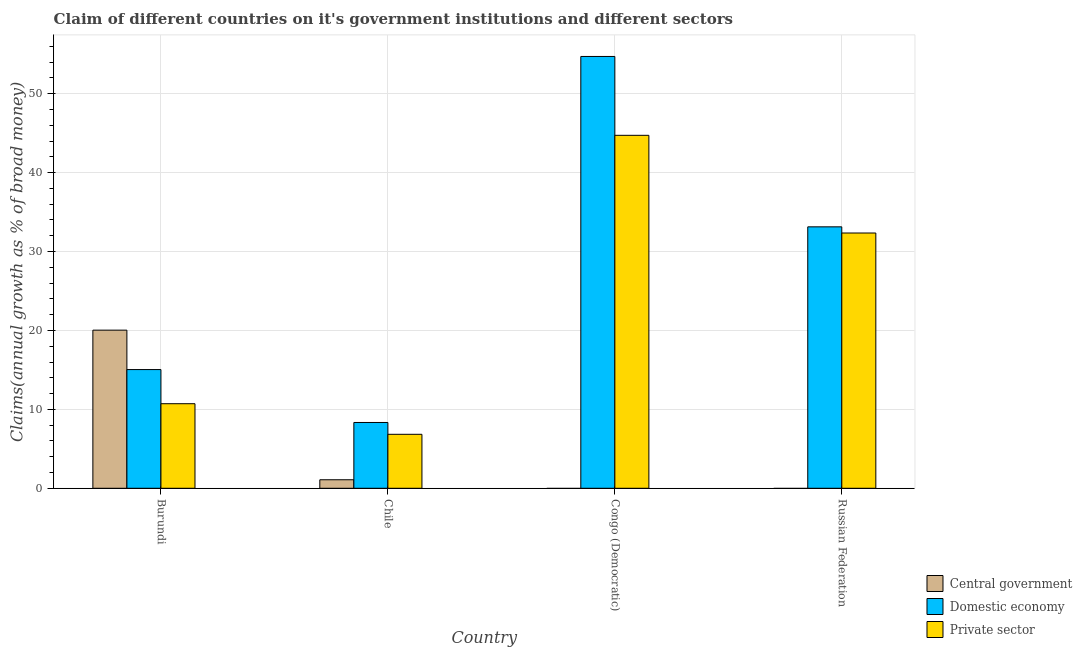How many different coloured bars are there?
Provide a succinct answer. 3. How many groups of bars are there?
Provide a succinct answer. 4. How many bars are there on the 3rd tick from the left?
Offer a very short reply. 2. What is the label of the 4th group of bars from the left?
Your answer should be very brief. Russian Federation. In how many cases, is the number of bars for a given country not equal to the number of legend labels?
Keep it short and to the point. 2. What is the percentage of claim on the domestic economy in Burundi?
Your answer should be very brief. 15.04. Across all countries, what is the maximum percentage of claim on the central government?
Provide a succinct answer. 20.04. Across all countries, what is the minimum percentage of claim on the central government?
Provide a succinct answer. 0. In which country was the percentage of claim on the domestic economy maximum?
Your answer should be very brief. Congo (Democratic). What is the total percentage of claim on the domestic economy in the graph?
Your answer should be compact. 111.22. What is the difference between the percentage of claim on the domestic economy in Burundi and that in Chile?
Your answer should be very brief. 6.7. What is the difference between the percentage of claim on the central government in Burundi and the percentage of claim on the domestic economy in Russian Federation?
Provide a succinct answer. -13.09. What is the average percentage of claim on the private sector per country?
Your response must be concise. 23.65. What is the difference between the percentage of claim on the private sector and percentage of claim on the central government in Burundi?
Make the answer very short. -9.32. In how many countries, is the percentage of claim on the private sector greater than 32 %?
Offer a very short reply. 2. What is the ratio of the percentage of claim on the private sector in Chile to that in Congo (Democratic)?
Your answer should be compact. 0.15. Is the percentage of claim on the domestic economy in Burundi less than that in Russian Federation?
Your answer should be very brief. Yes. Is the difference between the percentage of claim on the domestic economy in Chile and Russian Federation greater than the difference between the percentage of claim on the private sector in Chile and Russian Federation?
Ensure brevity in your answer.  Yes. What is the difference between the highest and the second highest percentage of claim on the private sector?
Provide a short and direct response. 12.38. What is the difference between the highest and the lowest percentage of claim on the central government?
Provide a succinct answer. 20.04. How many bars are there?
Your response must be concise. 10. Are all the bars in the graph horizontal?
Your answer should be compact. No. Does the graph contain grids?
Offer a terse response. Yes. How many legend labels are there?
Ensure brevity in your answer.  3. How are the legend labels stacked?
Offer a terse response. Vertical. What is the title of the graph?
Your response must be concise. Claim of different countries on it's government institutions and different sectors. What is the label or title of the X-axis?
Provide a succinct answer. Country. What is the label or title of the Y-axis?
Ensure brevity in your answer.  Claims(annual growth as % of broad money). What is the Claims(annual growth as % of broad money) of Central government in Burundi?
Your response must be concise. 20.04. What is the Claims(annual growth as % of broad money) of Domestic economy in Burundi?
Make the answer very short. 15.04. What is the Claims(annual growth as % of broad money) in Private sector in Burundi?
Your answer should be compact. 10.72. What is the Claims(annual growth as % of broad money) of Central government in Chile?
Your answer should be very brief. 1.08. What is the Claims(annual growth as % of broad money) in Domestic economy in Chile?
Provide a succinct answer. 8.34. What is the Claims(annual growth as % of broad money) in Private sector in Chile?
Keep it short and to the point. 6.84. What is the Claims(annual growth as % of broad money) of Central government in Congo (Democratic)?
Keep it short and to the point. 0. What is the Claims(annual growth as % of broad money) of Domestic economy in Congo (Democratic)?
Your response must be concise. 54.71. What is the Claims(annual growth as % of broad money) of Private sector in Congo (Democratic)?
Your response must be concise. 44.72. What is the Claims(annual growth as % of broad money) of Central government in Russian Federation?
Offer a terse response. 0. What is the Claims(annual growth as % of broad money) of Domestic economy in Russian Federation?
Provide a short and direct response. 33.13. What is the Claims(annual growth as % of broad money) of Private sector in Russian Federation?
Your response must be concise. 32.34. Across all countries, what is the maximum Claims(annual growth as % of broad money) of Central government?
Your answer should be very brief. 20.04. Across all countries, what is the maximum Claims(annual growth as % of broad money) of Domestic economy?
Provide a succinct answer. 54.71. Across all countries, what is the maximum Claims(annual growth as % of broad money) in Private sector?
Your response must be concise. 44.72. Across all countries, what is the minimum Claims(annual growth as % of broad money) in Domestic economy?
Make the answer very short. 8.34. Across all countries, what is the minimum Claims(annual growth as % of broad money) in Private sector?
Keep it short and to the point. 6.84. What is the total Claims(annual growth as % of broad money) of Central government in the graph?
Provide a succinct answer. 21.12. What is the total Claims(annual growth as % of broad money) of Domestic economy in the graph?
Your answer should be very brief. 111.22. What is the total Claims(annual growth as % of broad money) of Private sector in the graph?
Keep it short and to the point. 94.62. What is the difference between the Claims(annual growth as % of broad money) of Central government in Burundi and that in Chile?
Ensure brevity in your answer.  18.96. What is the difference between the Claims(annual growth as % of broad money) of Domestic economy in Burundi and that in Chile?
Offer a very short reply. 6.7. What is the difference between the Claims(annual growth as % of broad money) in Private sector in Burundi and that in Chile?
Your answer should be very brief. 3.88. What is the difference between the Claims(annual growth as % of broad money) of Domestic economy in Burundi and that in Congo (Democratic)?
Keep it short and to the point. -39.67. What is the difference between the Claims(annual growth as % of broad money) in Private sector in Burundi and that in Congo (Democratic)?
Provide a succinct answer. -34.01. What is the difference between the Claims(annual growth as % of broad money) in Domestic economy in Burundi and that in Russian Federation?
Make the answer very short. -18.08. What is the difference between the Claims(annual growth as % of broad money) in Private sector in Burundi and that in Russian Federation?
Offer a terse response. -21.63. What is the difference between the Claims(annual growth as % of broad money) in Domestic economy in Chile and that in Congo (Democratic)?
Your answer should be compact. -46.37. What is the difference between the Claims(annual growth as % of broad money) of Private sector in Chile and that in Congo (Democratic)?
Your answer should be compact. -37.88. What is the difference between the Claims(annual growth as % of broad money) of Domestic economy in Chile and that in Russian Federation?
Your answer should be compact. -24.79. What is the difference between the Claims(annual growth as % of broad money) of Private sector in Chile and that in Russian Federation?
Ensure brevity in your answer.  -25.51. What is the difference between the Claims(annual growth as % of broad money) in Domestic economy in Congo (Democratic) and that in Russian Federation?
Your answer should be very brief. 21.59. What is the difference between the Claims(annual growth as % of broad money) in Private sector in Congo (Democratic) and that in Russian Federation?
Give a very brief answer. 12.38. What is the difference between the Claims(annual growth as % of broad money) of Central government in Burundi and the Claims(annual growth as % of broad money) of Domestic economy in Chile?
Offer a very short reply. 11.7. What is the difference between the Claims(annual growth as % of broad money) in Central government in Burundi and the Claims(annual growth as % of broad money) in Private sector in Chile?
Your response must be concise. 13.2. What is the difference between the Claims(annual growth as % of broad money) in Domestic economy in Burundi and the Claims(annual growth as % of broad money) in Private sector in Chile?
Provide a short and direct response. 8.2. What is the difference between the Claims(annual growth as % of broad money) of Central government in Burundi and the Claims(annual growth as % of broad money) of Domestic economy in Congo (Democratic)?
Offer a terse response. -34.68. What is the difference between the Claims(annual growth as % of broad money) in Central government in Burundi and the Claims(annual growth as % of broad money) in Private sector in Congo (Democratic)?
Your answer should be very brief. -24.69. What is the difference between the Claims(annual growth as % of broad money) in Domestic economy in Burundi and the Claims(annual growth as % of broad money) in Private sector in Congo (Democratic)?
Ensure brevity in your answer.  -29.68. What is the difference between the Claims(annual growth as % of broad money) of Central government in Burundi and the Claims(annual growth as % of broad money) of Domestic economy in Russian Federation?
Keep it short and to the point. -13.09. What is the difference between the Claims(annual growth as % of broad money) of Central government in Burundi and the Claims(annual growth as % of broad money) of Private sector in Russian Federation?
Provide a short and direct response. -12.31. What is the difference between the Claims(annual growth as % of broad money) in Domestic economy in Burundi and the Claims(annual growth as % of broad money) in Private sector in Russian Federation?
Your answer should be compact. -17.3. What is the difference between the Claims(annual growth as % of broad money) in Central government in Chile and the Claims(annual growth as % of broad money) in Domestic economy in Congo (Democratic)?
Your answer should be compact. -53.63. What is the difference between the Claims(annual growth as % of broad money) in Central government in Chile and the Claims(annual growth as % of broad money) in Private sector in Congo (Democratic)?
Offer a very short reply. -43.64. What is the difference between the Claims(annual growth as % of broad money) in Domestic economy in Chile and the Claims(annual growth as % of broad money) in Private sector in Congo (Democratic)?
Keep it short and to the point. -36.38. What is the difference between the Claims(annual growth as % of broad money) of Central government in Chile and the Claims(annual growth as % of broad money) of Domestic economy in Russian Federation?
Ensure brevity in your answer.  -32.05. What is the difference between the Claims(annual growth as % of broad money) in Central government in Chile and the Claims(annual growth as % of broad money) in Private sector in Russian Federation?
Provide a short and direct response. -31.26. What is the difference between the Claims(annual growth as % of broad money) of Domestic economy in Chile and the Claims(annual growth as % of broad money) of Private sector in Russian Federation?
Your response must be concise. -24.01. What is the difference between the Claims(annual growth as % of broad money) of Domestic economy in Congo (Democratic) and the Claims(annual growth as % of broad money) of Private sector in Russian Federation?
Offer a terse response. 22.37. What is the average Claims(annual growth as % of broad money) of Central government per country?
Ensure brevity in your answer.  5.28. What is the average Claims(annual growth as % of broad money) of Domestic economy per country?
Keep it short and to the point. 27.8. What is the average Claims(annual growth as % of broad money) in Private sector per country?
Your answer should be compact. 23.66. What is the difference between the Claims(annual growth as % of broad money) of Central government and Claims(annual growth as % of broad money) of Domestic economy in Burundi?
Your answer should be very brief. 4.99. What is the difference between the Claims(annual growth as % of broad money) of Central government and Claims(annual growth as % of broad money) of Private sector in Burundi?
Your answer should be compact. 9.32. What is the difference between the Claims(annual growth as % of broad money) of Domestic economy and Claims(annual growth as % of broad money) of Private sector in Burundi?
Provide a short and direct response. 4.33. What is the difference between the Claims(annual growth as % of broad money) in Central government and Claims(annual growth as % of broad money) in Domestic economy in Chile?
Provide a succinct answer. -7.26. What is the difference between the Claims(annual growth as % of broad money) in Central government and Claims(annual growth as % of broad money) in Private sector in Chile?
Ensure brevity in your answer.  -5.76. What is the difference between the Claims(annual growth as % of broad money) of Domestic economy and Claims(annual growth as % of broad money) of Private sector in Chile?
Offer a very short reply. 1.5. What is the difference between the Claims(annual growth as % of broad money) in Domestic economy and Claims(annual growth as % of broad money) in Private sector in Congo (Democratic)?
Provide a short and direct response. 9.99. What is the difference between the Claims(annual growth as % of broad money) in Domestic economy and Claims(annual growth as % of broad money) in Private sector in Russian Federation?
Your answer should be compact. 0.78. What is the ratio of the Claims(annual growth as % of broad money) in Central government in Burundi to that in Chile?
Keep it short and to the point. 18.55. What is the ratio of the Claims(annual growth as % of broad money) in Domestic economy in Burundi to that in Chile?
Ensure brevity in your answer.  1.8. What is the ratio of the Claims(annual growth as % of broad money) in Private sector in Burundi to that in Chile?
Give a very brief answer. 1.57. What is the ratio of the Claims(annual growth as % of broad money) of Domestic economy in Burundi to that in Congo (Democratic)?
Provide a short and direct response. 0.27. What is the ratio of the Claims(annual growth as % of broad money) of Private sector in Burundi to that in Congo (Democratic)?
Offer a very short reply. 0.24. What is the ratio of the Claims(annual growth as % of broad money) of Domestic economy in Burundi to that in Russian Federation?
Offer a terse response. 0.45. What is the ratio of the Claims(annual growth as % of broad money) of Private sector in Burundi to that in Russian Federation?
Make the answer very short. 0.33. What is the ratio of the Claims(annual growth as % of broad money) in Domestic economy in Chile to that in Congo (Democratic)?
Ensure brevity in your answer.  0.15. What is the ratio of the Claims(annual growth as % of broad money) of Private sector in Chile to that in Congo (Democratic)?
Keep it short and to the point. 0.15. What is the ratio of the Claims(annual growth as % of broad money) of Domestic economy in Chile to that in Russian Federation?
Offer a very short reply. 0.25. What is the ratio of the Claims(annual growth as % of broad money) of Private sector in Chile to that in Russian Federation?
Your response must be concise. 0.21. What is the ratio of the Claims(annual growth as % of broad money) of Domestic economy in Congo (Democratic) to that in Russian Federation?
Make the answer very short. 1.65. What is the ratio of the Claims(annual growth as % of broad money) in Private sector in Congo (Democratic) to that in Russian Federation?
Your answer should be very brief. 1.38. What is the difference between the highest and the second highest Claims(annual growth as % of broad money) in Domestic economy?
Keep it short and to the point. 21.59. What is the difference between the highest and the second highest Claims(annual growth as % of broad money) of Private sector?
Keep it short and to the point. 12.38. What is the difference between the highest and the lowest Claims(annual growth as % of broad money) in Central government?
Your answer should be very brief. 20.04. What is the difference between the highest and the lowest Claims(annual growth as % of broad money) of Domestic economy?
Offer a terse response. 46.37. What is the difference between the highest and the lowest Claims(annual growth as % of broad money) of Private sector?
Provide a short and direct response. 37.88. 